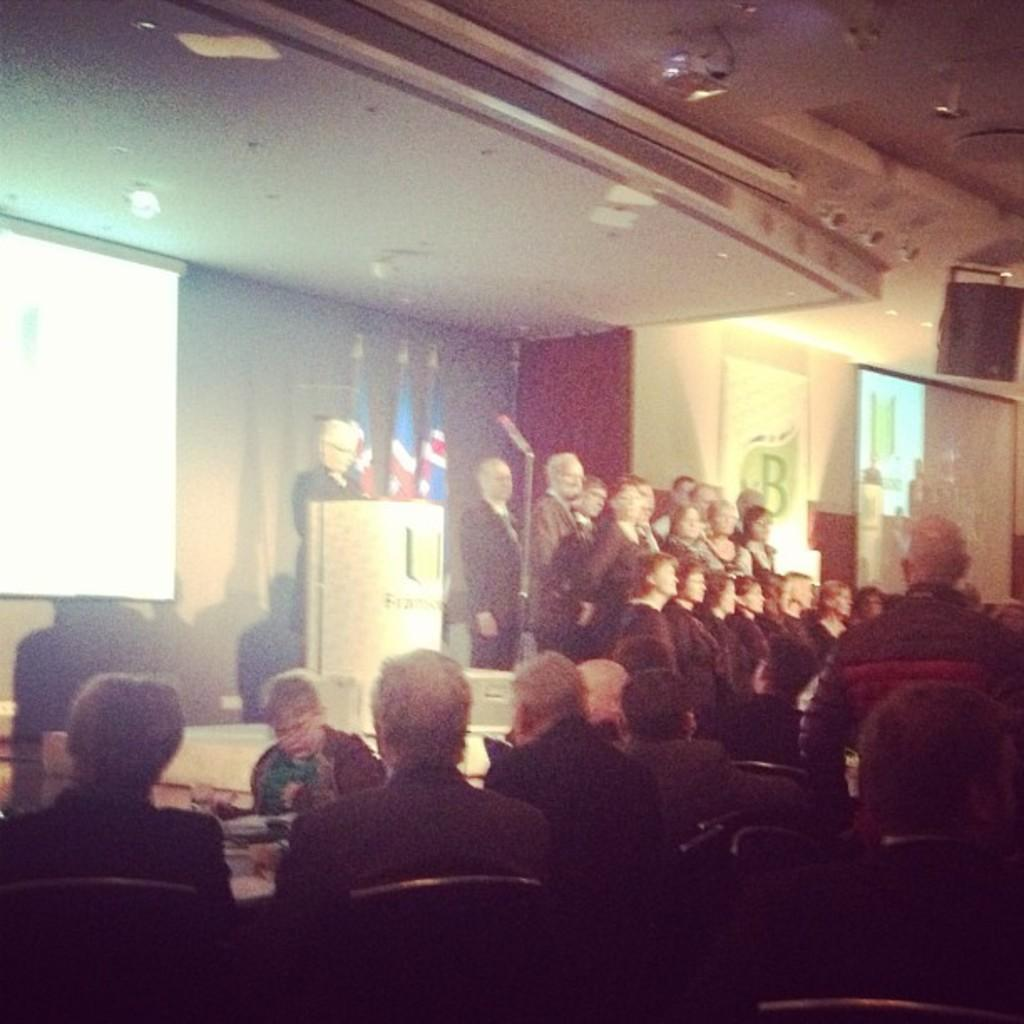How many people are in the image? There is a group of people in the image, but the exact number cannot be determined from the provided facts. What structure can be seen in the image? There is a podium in the image. What device is used for amplifying sound in the image? A microphone is present in the image. What national symbols are visible in the image? There are flags in the image. How does the ground twist in the image? There is no mention of the ground or any twisting in the image; the facts only mention a group of people, a podium, a microphone, and flags. 